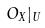<formula> <loc_0><loc_0><loc_500><loc_500>O _ { X } | _ { U }</formula> 